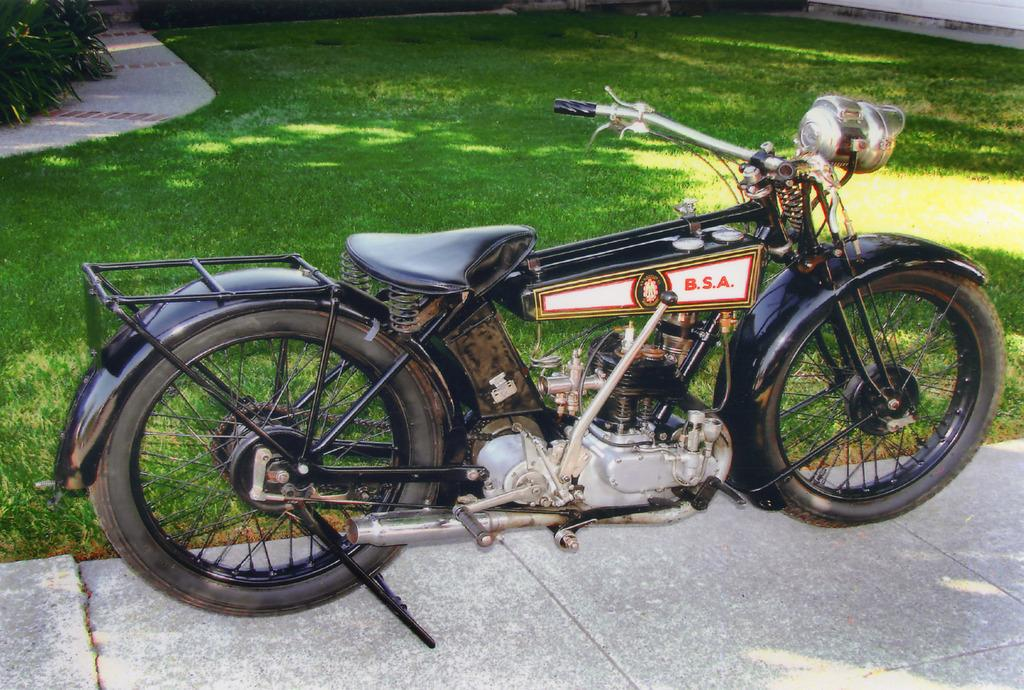What type of motor vehicle is in the image? The facts provided do not specify the type of motor vehicle. Where is the motor vehicle located in the image? The motor vehicle is placed on the ground. What type of natural environment is visible in the image? There is grass and plants visible in the image. What type of error can be seen in the image? There is no error present in the image. How does the motor vehicle contribute to the expansion of the city in the image? The facts provided do not mention any city or expansion, so this cannot be answered. 